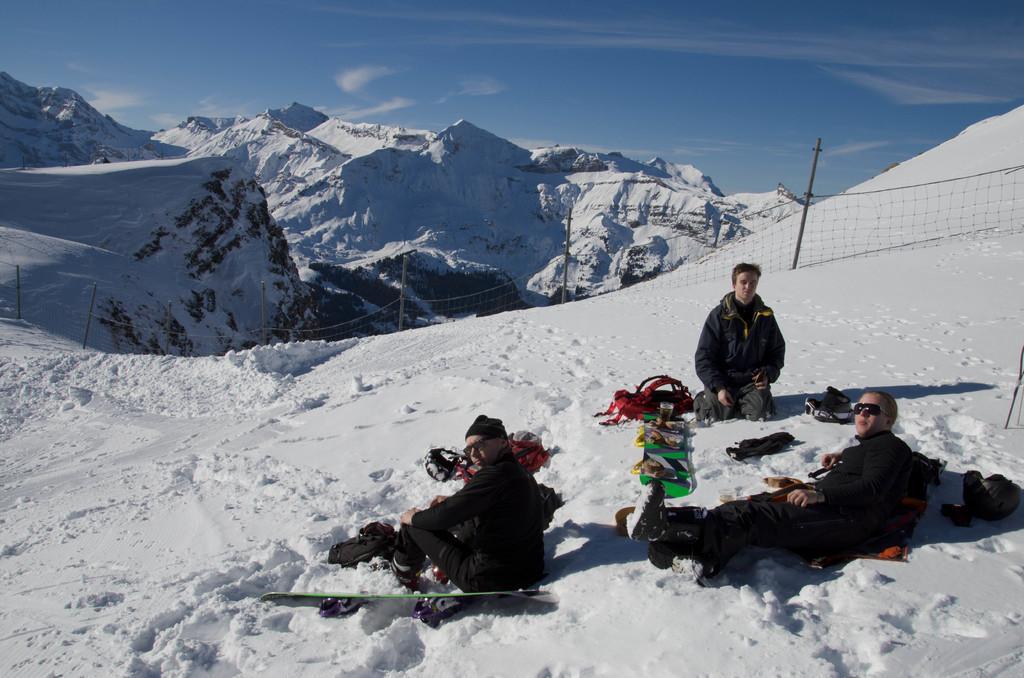Could you give a brief overview of what you see in this image? In this image we can see people sitting on the snow and there are ski boards. In the background there are hills, fence and sky. There is snow. 